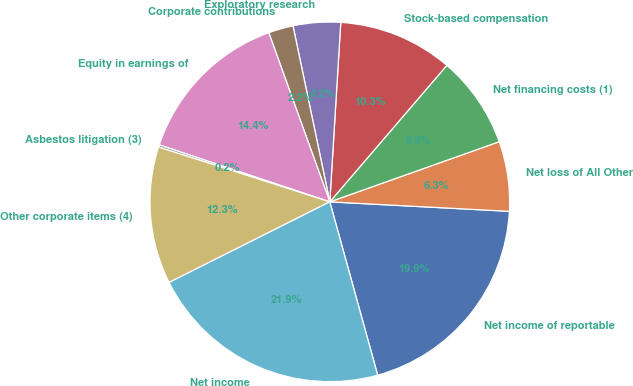<chart> <loc_0><loc_0><loc_500><loc_500><pie_chart><fcel>Net income of reportable<fcel>Net loss of All Other<fcel>Net financing costs (1)<fcel>Stock-based compensation<fcel>Exploratory research<fcel>Corporate contributions<fcel>Equity in earnings of<fcel>Asbestos litigation (3)<fcel>Other corporate items (4)<fcel>Net income<nl><fcel>19.87%<fcel>6.27%<fcel>8.29%<fcel>10.31%<fcel>4.25%<fcel>2.23%<fcel>14.36%<fcel>0.2%<fcel>12.33%<fcel>21.89%<nl></chart> 